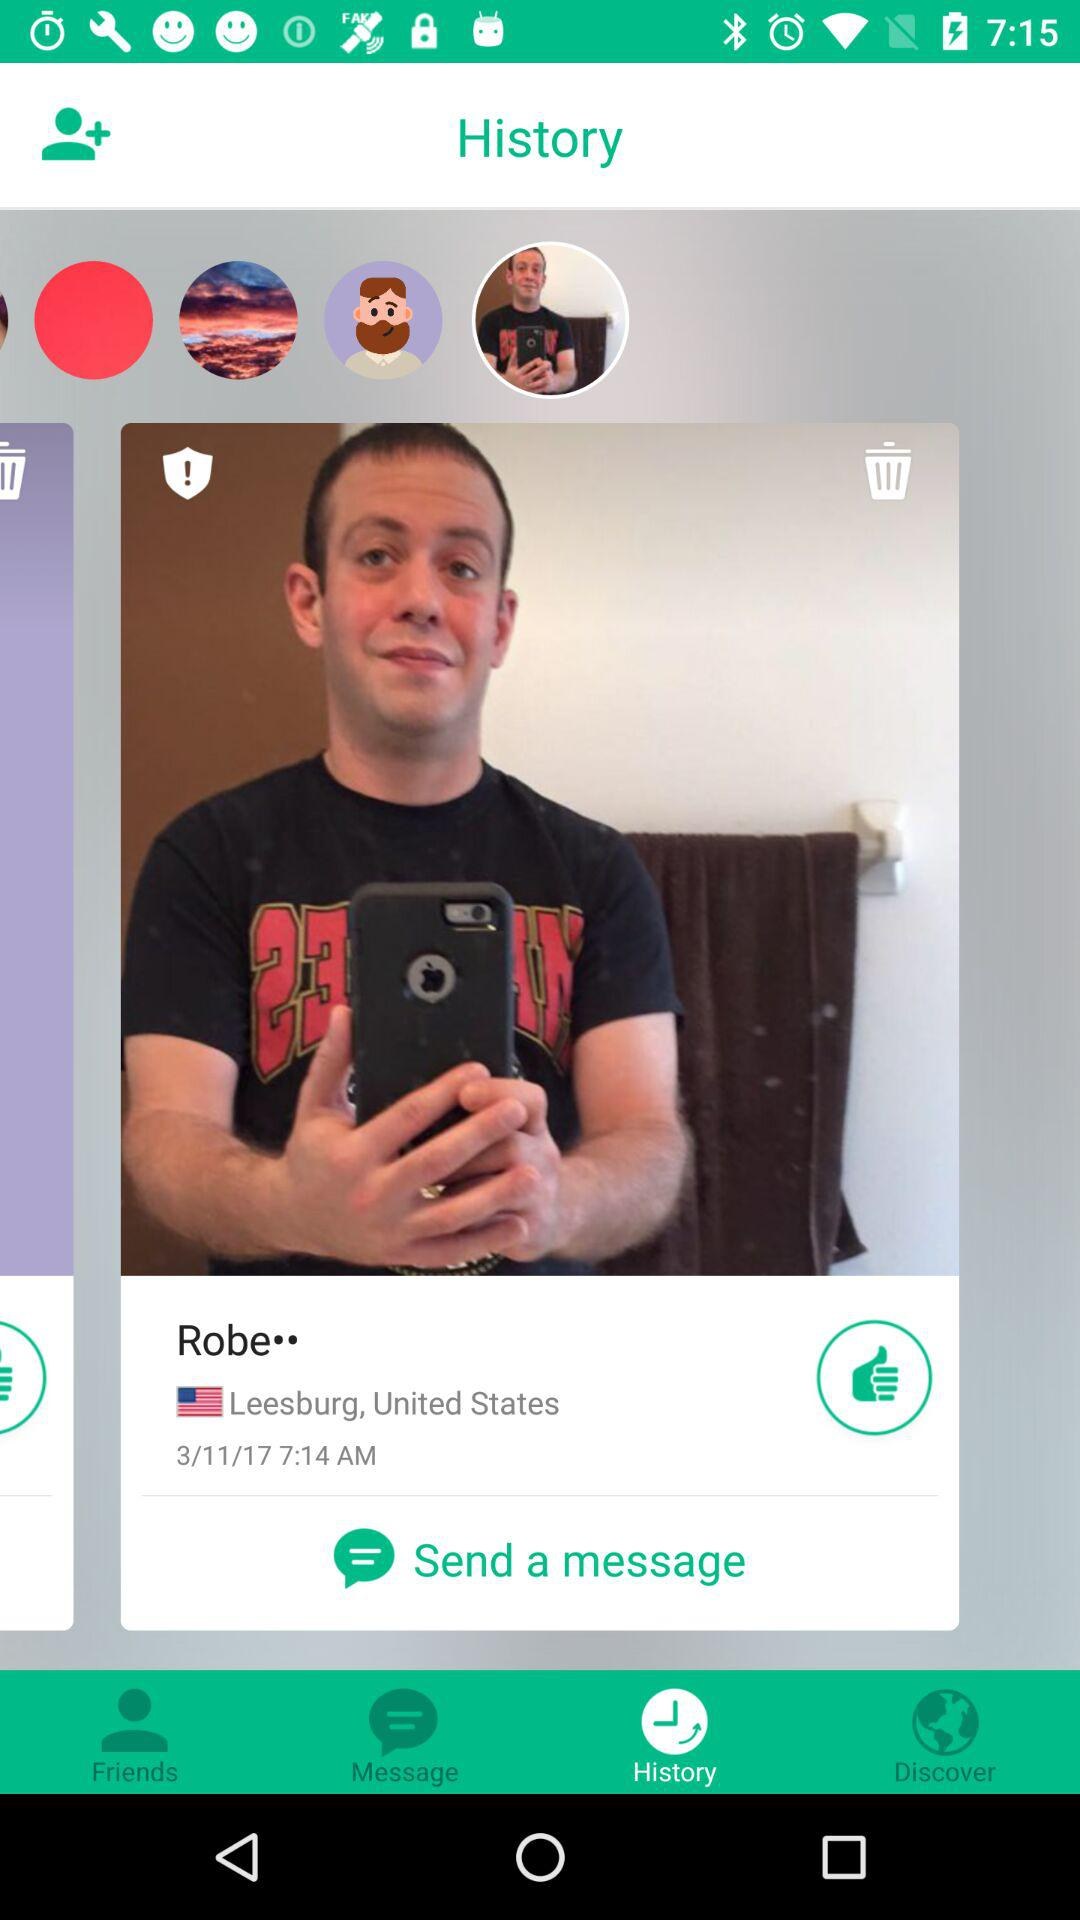What is the date? The date is 3/11/17. 